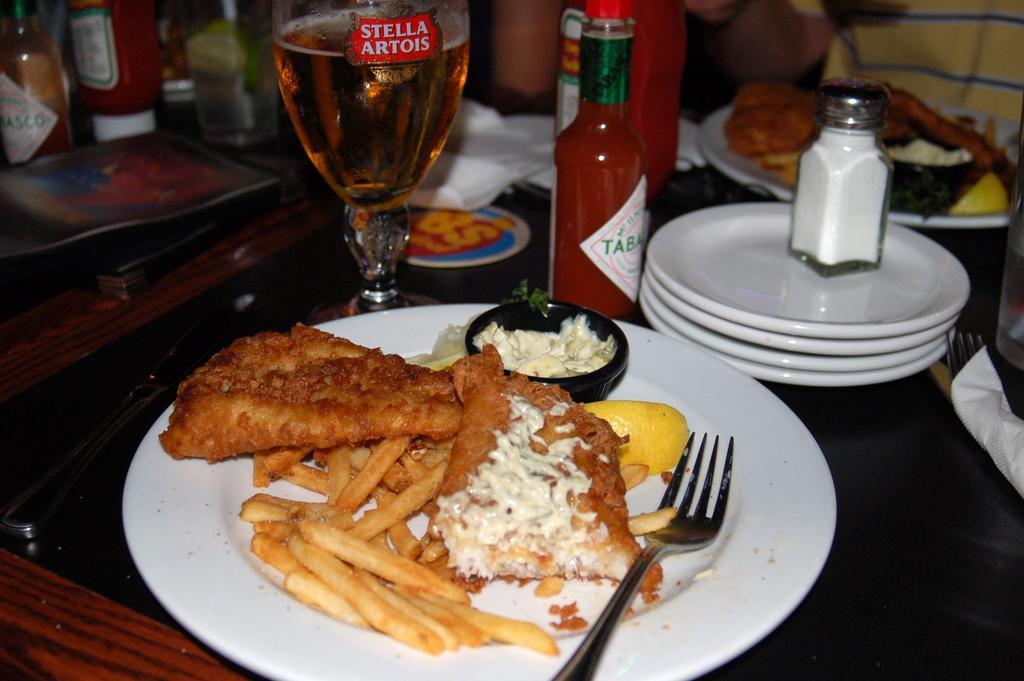How would you summarize this image in a sentence or two? In this image we can see some food items, plate, fork and knife and other objects on an object. In the background of the image there are some plates, bottles, a person, food items and some other objects. 